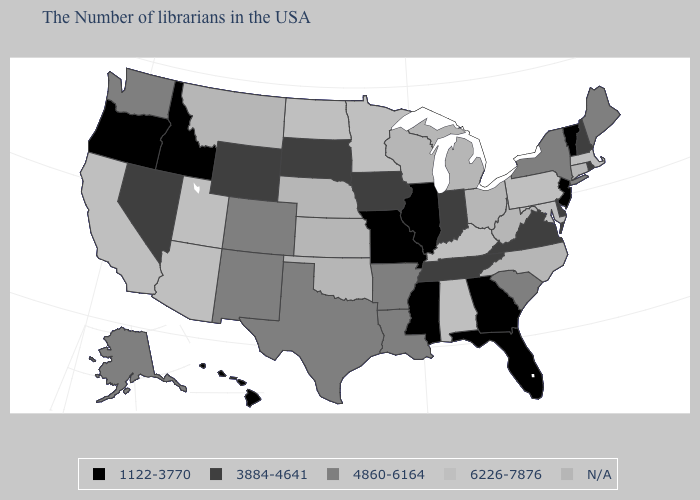Name the states that have a value in the range 1122-3770?
Be succinct. Vermont, New Jersey, Florida, Georgia, Illinois, Mississippi, Missouri, Idaho, Oregon, Hawaii. What is the lowest value in states that border Maryland?
Keep it brief. 3884-4641. What is the highest value in the USA?
Answer briefly. 6226-7876. Among the states that border Virginia , does Tennessee have the highest value?
Answer briefly. No. Which states have the lowest value in the South?
Be succinct. Florida, Georgia, Mississippi. Name the states that have a value in the range 1122-3770?
Short answer required. Vermont, New Jersey, Florida, Georgia, Illinois, Mississippi, Missouri, Idaho, Oregon, Hawaii. What is the value of New Jersey?
Answer briefly. 1122-3770. Name the states that have a value in the range 4860-6164?
Be succinct. Maine, New York, South Carolina, Louisiana, Arkansas, Texas, Colorado, New Mexico, Washington, Alaska. Is the legend a continuous bar?
Keep it brief. No. Which states have the highest value in the USA?
Give a very brief answer. Massachusetts, Maryland, Pennsylvania, Kentucky, Alabama, Minnesota, North Dakota, Utah, Arizona, California. Among the states that border Oklahoma , does Texas have the lowest value?
Be succinct. No. Name the states that have a value in the range 6226-7876?
Write a very short answer. Massachusetts, Maryland, Pennsylvania, Kentucky, Alabama, Minnesota, North Dakota, Utah, Arizona, California. Name the states that have a value in the range 3884-4641?
Concise answer only. Rhode Island, New Hampshire, Delaware, Virginia, Indiana, Tennessee, Iowa, South Dakota, Wyoming, Nevada. What is the lowest value in states that border Wyoming?
Concise answer only. 1122-3770. Which states have the lowest value in the USA?
Keep it brief. Vermont, New Jersey, Florida, Georgia, Illinois, Mississippi, Missouri, Idaho, Oregon, Hawaii. 